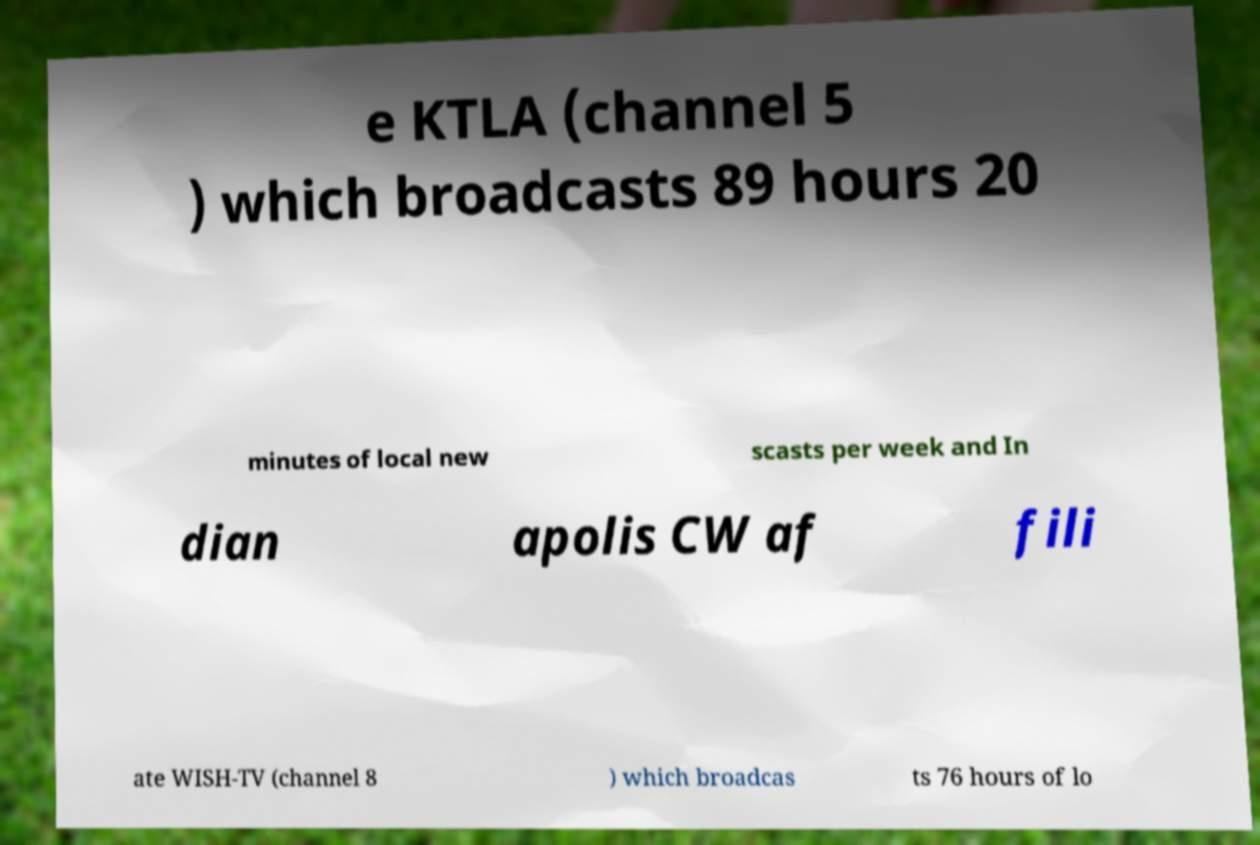I need the written content from this picture converted into text. Can you do that? e KTLA (channel 5 ) which broadcasts 89 hours 20 minutes of local new scasts per week and In dian apolis CW af fili ate WISH-TV (channel 8 ) which broadcas ts 76 hours of lo 